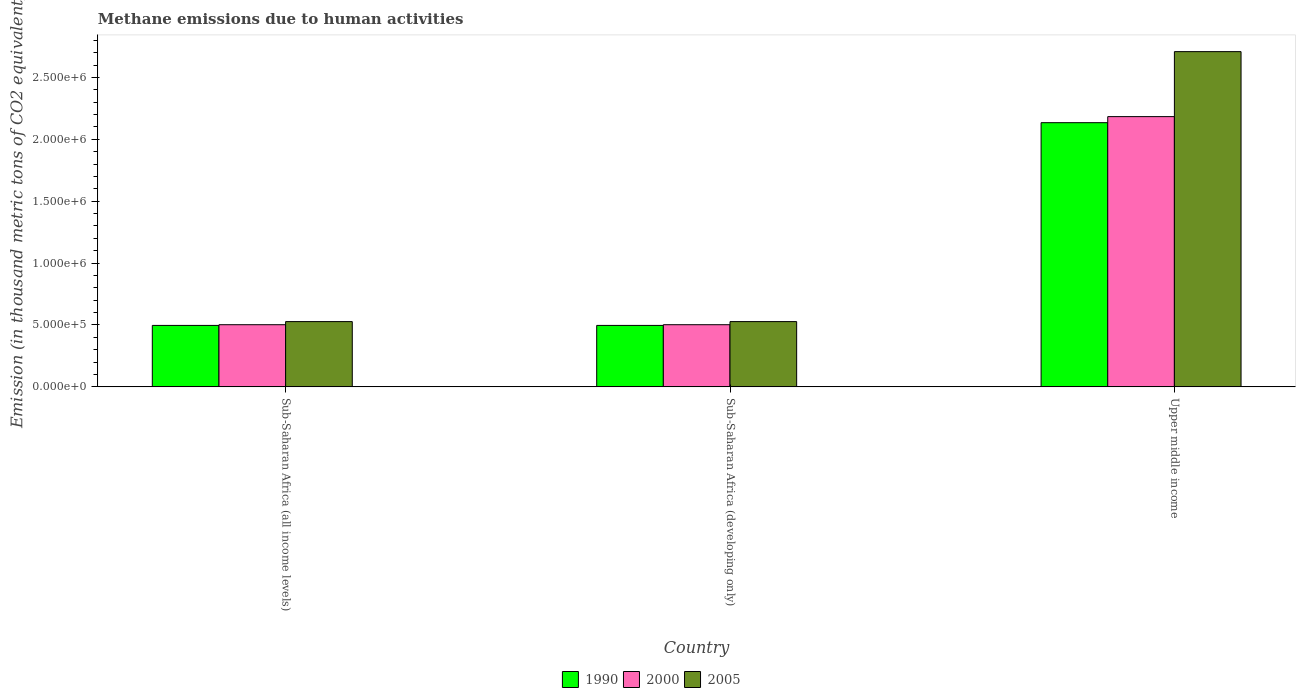How many different coloured bars are there?
Ensure brevity in your answer.  3. Are the number of bars per tick equal to the number of legend labels?
Your response must be concise. Yes. Are the number of bars on each tick of the X-axis equal?
Keep it short and to the point. Yes. How many bars are there on the 3rd tick from the left?
Ensure brevity in your answer.  3. How many bars are there on the 2nd tick from the right?
Your response must be concise. 3. What is the label of the 1st group of bars from the left?
Ensure brevity in your answer.  Sub-Saharan Africa (all income levels). In how many cases, is the number of bars for a given country not equal to the number of legend labels?
Provide a short and direct response. 0. What is the amount of methane emitted in 1990 in Sub-Saharan Africa (developing only)?
Make the answer very short. 4.97e+05. Across all countries, what is the maximum amount of methane emitted in 2005?
Your answer should be compact. 2.71e+06. Across all countries, what is the minimum amount of methane emitted in 2000?
Provide a succinct answer. 5.02e+05. In which country was the amount of methane emitted in 2005 maximum?
Your response must be concise. Upper middle income. In which country was the amount of methane emitted in 2005 minimum?
Your response must be concise. Sub-Saharan Africa (all income levels). What is the total amount of methane emitted in 2005 in the graph?
Your answer should be compact. 3.76e+06. What is the difference between the amount of methane emitted in 2000 in Sub-Saharan Africa (developing only) and that in Upper middle income?
Your answer should be very brief. -1.68e+06. What is the difference between the amount of methane emitted in 1990 in Upper middle income and the amount of methane emitted in 2005 in Sub-Saharan Africa (all income levels)?
Your answer should be compact. 1.61e+06. What is the average amount of methane emitted in 2000 per country?
Your answer should be compact. 1.06e+06. What is the difference between the amount of methane emitted of/in 1990 and amount of methane emitted of/in 2005 in Upper middle income?
Offer a terse response. -5.74e+05. What is the ratio of the amount of methane emitted in 2000 in Sub-Saharan Africa (all income levels) to that in Sub-Saharan Africa (developing only)?
Provide a short and direct response. 1. Is the difference between the amount of methane emitted in 1990 in Sub-Saharan Africa (developing only) and Upper middle income greater than the difference between the amount of methane emitted in 2005 in Sub-Saharan Africa (developing only) and Upper middle income?
Your response must be concise. Yes. What is the difference between the highest and the second highest amount of methane emitted in 1990?
Your answer should be very brief. -1.64e+06. What is the difference between the highest and the lowest amount of methane emitted in 2005?
Ensure brevity in your answer.  2.18e+06. In how many countries, is the amount of methane emitted in 2005 greater than the average amount of methane emitted in 2005 taken over all countries?
Your answer should be very brief. 1. Is the sum of the amount of methane emitted in 2005 in Sub-Saharan Africa (developing only) and Upper middle income greater than the maximum amount of methane emitted in 1990 across all countries?
Ensure brevity in your answer.  Yes. What does the 2nd bar from the left in Sub-Saharan Africa (all income levels) represents?
Offer a terse response. 2000. Is it the case that in every country, the sum of the amount of methane emitted in 1990 and amount of methane emitted in 2000 is greater than the amount of methane emitted in 2005?
Your answer should be very brief. Yes. How many bars are there?
Provide a succinct answer. 9. Are all the bars in the graph horizontal?
Your answer should be compact. No. How many countries are there in the graph?
Your answer should be very brief. 3. What is the difference between two consecutive major ticks on the Y-axis?
Your answer should be very brief. 5.00e+05. Does the graph contain any zero values?
Your answer should be compact. No. How are the legend labels stacked?
Your answer should be compact. Horizontal. What is the title of the graph?
Offer a very short reply. Methane emissions due to human activities. What is the label or title of the X-axis?
Offer a very short reply. Country. What is the label or title of the Y-axis?
Your answer should be compact. Emission (in thousand metric tons of CO2 equivalent). What is the Emission (in thousand metric tons of CO2 equivalent) of 1990 in Sub-Saharan Africa (all income levels)?
Provide a succinct answer. 4.97e+05. What is the Emission (in thousand metric tons of CO2 equivalent) of 2000 in Sub-Saharan Africa (all income levels)?
Offer a very short reply. 5.02e+05. What is the Emission (in thousand metric tons of CO2 equivalent) in 2005 in Sub-Saharan Africa (all income levels)?
Offer a terse response. 5.27e+05. What is the Emission (in thousand metric tons of CO2 equivalent) in 1990 in Sub-Saharan Africa (developing only)?
Your answer should be very brief. 4.97e+05. What is the Emission (in thousand metric tons of CO2 equivalent) of 2000 in Sub-Saharan Africa (developing only)?
Provide a succinct answer. 5.02e+05. What is the Emission (in thousand metric tons of CO2 equivalent) of 2005 in Sub-Saharan Africa (developing only)?
Give a very brief answer. 5.27e+05. What is the Emission (in thousand metric tons of CO2 equivalent) of 1990 in Upper middle income?
Keep it short and to the point. 2.13e+06. What is the Emission (in thousand metric tons of CO2 equivalent) in 2000 in Upper middle income?
Make the answer very short. 2.18e+06. What is the Emission (in thousand metric tons of CO2 equivalent) in 2005 in Upper middle income?
Provide a short and direct response. 2.71e+06. Across all countries, what is the maximum Emission (in thousand metric tons of CO2 equivalent) in 1990?
Provide a succinct answer. 2.13e+06. Across all countries, what is the maximum Emission (in thousand metric tons of CO2 equivalent) in 2000?
Your answer should be compact. 2.18e+06. Across all countries, what is the maximum Emission (in thousand metric tons of CO2 equivalent) in 2005?
Your response must be concise. 2.71e+06. Across all countries, what is the minimum Emission (in thousand metric tons of CO2 equivalent) in 1990?
Your response must be concise. 4.97e+05. Across all countries, what is the minimum Emission (in thousand metric tons of CO2 equivalent) of 2000?
Provide a short and direct response. 5.02e+05. Across all countries, what is the minimum Emission (in thousand metric tons of CO2 equivalent) in 2005?
Keep it short and to the point. 5.27e+05. What is the total Emission (in thousand metric tons of CO2 equivalent) of 1990 in the graph?
Your answer should be very brief. 3.13e+06. What is the total Emission (in thousand metric tons of CO2 equivalent) in 2000 in the graph?
Your answer should be compact. 3.19e+06. What is the total Emission (in thousand metric tons of CO2 equivalent) of 2005 in the graph?
Your answer should be compact. 3.76e+06. What is the difference between the Emission (in thousand metric tons of CO2 equivalent) of 1990 in Sub-Saharan Africa (all income levels) and that in Sub-Saharan Africa (developing only)?
Provide a succinct answer. 0. What is the difference between the Emission (in thousand metric tons of CO2 equivalent) of 1990 in Sub-Saharan Africa (all income levels) and that in Upper middle income?
Offer a very short reply. -1.64e+06. What is the difference between the Emission (in thousand metric tons of CO2 equivalent) in 2000 in Sub-Saharan Africa (all income levels) and that in Upper middle income?
Ensure brevity in your answer.  -1.68e+06. What is the difference between the Emission (in thousand metric tons of CO2 equivalent) of 2005 in Sub-Saharan Africa (all income levels) and that in Upper middle income?
Keep it short and to the point. -2.18e+06. What is the difference between the Emission (in thousand metric tons of CO2 equivalent) of 1990 in Sub-Saharan Africa (developing only) and that in Upper middle income?
Provide a short and direct response. -1.64e+06. What is the difference between the Emission (in thousand metric tons of CO2 equivalent) in 2000 in Sub-Saharan Africa (developing only) and that in Upper middle income?
Provide a short and direct response. -1.68e+06. What is the difference between the Emission (in thousand metric tons of CO2 equivalent) in 2005 in Sub-Saharan Africa (developing only) and that in Upper middle income?
Your answer should be very brief. -2.18e+06. What is the difference between the Emission (in thousand metric tons of CO2 equivalent) of 1990 in Sub-Saharan Africa (all income levels) and the Emission (in thousand metric tons of CO2 equivalent) of 2000 in Sub-Saharan Africa (developing only)?
Your answer should be very brief. -5608.2. What is the difference between the Emission (in thousand metric tons of CO2 equivalent) of 1990 in Sub-Saharan Africa (all income levels) and the Emission (in thousand metric tons of CO2 equivalent) of 2005 in Sub-Saharan Africa (developing only)?
Your answer should be very brief. -3.07e+04. What is the difference between the Emission (in thousand metric tons of CO2 equivalent) of 2000 in Sub-Saharan Africa (all income levels) and the Emission (in thousand metric tons of CO2 equivalent) of 2005 in Sub-Saharan Africa (developing only)?
Offer a very short reply. -2.51e+04. What is the difference between the Emission (in thousand metric tons of CO2 equivalent) of 1990 in Sub-Saharan Africa (all income levels) and the Emission (in thousand metric tons of CO2 equivalent) of 2000 in Upper middle income?
Your answer should be very brief. -1.69e+06. What is the difference between the Emission (in thousand metric tons of CO2 equivalent) of 1990 in Sub-Saharan Africa (all income levels) and the Emission (in thousand metric tons of CO2 equivalent) of 2005 in Upper middle income?
Keep it short and to the point. -2.21e+06. What is the difference between the Emission (in thousand metric tons of CO2 equivalent) in 2000 in Sub-Saharan Africa (all income levels) and the Emission (in thousand metric tons of CO2 equivalent) in 2005 in Upper middle income?
Your answer should be very brief. -2.21e+06. What is the difference between the Emission (in thousand metric tons of CO2 equivalent) in 1990 in Sub-Saharan Africa (developing only) and the Emission (in thousand metric tons of CO2 equivalent) in 2000 in Upper middle income?
Give a very brief answer. -1.69e+06. What is the difference between the Emission (in thousand metric tons of CO2 equivalent) of 1990 in Sub-Saharan Africa (developing only) and the Emission (in thousand metric tons of CO2 equivalent) of 2005 in Upper middle income?
Your answer should be compact. -2.21e+06. What is the difference between the Emission (in thousand metric tons of CO2 equivalent) in 2000 in Sub-Saharan Africa (developing only) and the Emission (in thousand metric tons of CO2 equivalent) in 2005 in Upper middle income?
Offer a very short reply. -2.21e+06. What is the average Emission (in thousand metric tons of CO2 equivalent) of 1990 per country?
Provide a short and direct response. 1.04e+06. What is the average Emission (in thousand metric tons of CO2 equivalent) of 2000 per country?
Make the answer very short. 1.06e+06. What is the average Emission (in thousand metric tons of CO2 equivalent) of 2005 per country?
Your response must be concise. 1.25e+06. What is the difference between the Emission (in thousand metric tons of CO2 equivalent) of 1990 and Emission (in thousand metric tons of CO2 equivalent) of 2000 in Sub-Saharan Africa (all income levels)?
Offer a terse response. -5608.2. What is the difference between the Emission (in thousand metric tons of CO2 equivalent) in 1990 and Emission (in thousand metric tons of CO2 equivalent) in 2005 in Sub-Saharan Africa (all income levels)?
Provide a short and direct response. -3.07e+04. What is the difference between the Emission (in thousand metric tons of CO2 equivalent) in 2000 and Emission (in thousand metric tons of CO2 equivalent) in 2005 in Sub-Saharan Africa (all income levels)?
Give a very brief answer. -2.51e+04. What is the difference between the Emission (in thousand metric tons of CO2 equivalent) in 1990 and Emission (in thousand metric tons of CO2 equivalent) in 2000 in Sub-Saharan Africa (developing only)?
Your response must be concise. -5608.2. What is the difference between the Emission (in thousand metric tons of CO2 equivalent) of 1990 and Emission (in thousand metric tons of CO2 equivalent) of 2005 in Sub-Saharan Africa (developing only)?
Provide a succinct answer. -3.07e+04. What is the difference between the Emission (in thousand metric tons of CO2 equivalent) of 2000 and Emission (in thousand metric tons of CO2 equivalent) of 2005 in Sub-Saharan Africa (developing only)?
Offer a very short reply. -2.51e+04. What is the difference between the Emission (in thousand metric tons of CO2 equivalent) of 1990 and Emission (in thousand metric tons of CO2 equivalent) of 2000 in Upper middle income?
Provide a short and direct response. -4.89e+04. What is the difference between the Emission (in thousand metric tons of CO2 equivalent) in 1990 and Emission (in thousand metric tons of CO2 equivalent) in 2005 in Upper middle income?
Your answer should be compact. -5.74e+05. What is the difference between the Emission (in thousand metric tons of CO2 equivalent) of 2000 and Emission (in thousand metric tons of CO2 equivalent) of 2005 in Upper middle income?
Your answer should be compact. -5.25e+05. What is the ratio of the Emission (in thousand metric tons of CO2 equivalent) of 2005 in Sub-Saharan Africa (all income levels) to that in Sub-Saharan Africa (developing only)?
Your response must be concise. 1. What is the ratio of the Emission (in thousand metric tons of CO2 equivalent) in 1990 in Sub-Saharan Africa (all income levels) to that in Upper middle income?
Give a very brief answer. 0.23. What is the ratio of the Emission (in thousand metric tons of CO2 equivalent) in 2000 in Sub-Saharan Africa (all income levels) to that in Upper middle income?
Your response must be concise. 0.23. What is the ratio of the Emission (in thousand metric tons of CO2 equivalent) in 2005 in Sub-Saharan Africa (all income levels) to that in Upper middle income?
Give a very brief answer. 0.19. What is the ratio of the Emission (in thousand metric tons of CO2 equivalent) in 1990 in Sub-Saharan Africa (developing only) to that in Upper middle income?
Ensure brevity in your answer.  0.23. What is the ratio of the Emission (in thousand metric tons of CO2 equivalent) of 2000 in Sub-Saharan Africa (developing only) to that in Upper middle income?
Your response must be concise. 0.23. What is the ratio of the Emission (in thousand metric tons of CO2 equivalent) in 2005 in Sub-Saharan Africa (developing only) to that in Upper middle income?
Give a very brief answer. 0.19. What is the difference between the highest and the second highest Emission (in thousand metric tons of CO2 equivalent) of 1990?
Your answer should be compact. 1.64e+06. What is the difference between the highest and the second highest Emission (in thousand metric tons of CO2 equivalent) of 2000?
Provide a succinct answer. 1.68e+06. What is the difference between the highest and the second highest Emission (in thousand metric tons of CO2 equivalent) of 2005?
Provide a succinct answer. 2.18e+06. What is the difference between the highest and the lowest Emission (in thousand metric tons of CO2 equivalent) in 1990?
Offer a very short reply. 1.64e+06. What is the difference between the highest and the lowest Emission (in thousand metric tons of CO2 equivalent) in 2000?
Offer a very short reply. 1.68e+06. What is the difference between the highest and the lowest Emission (in thousand metric tons of CO2 equivalent) in 2005?
Your answer should be compact. 2.18e+06. 